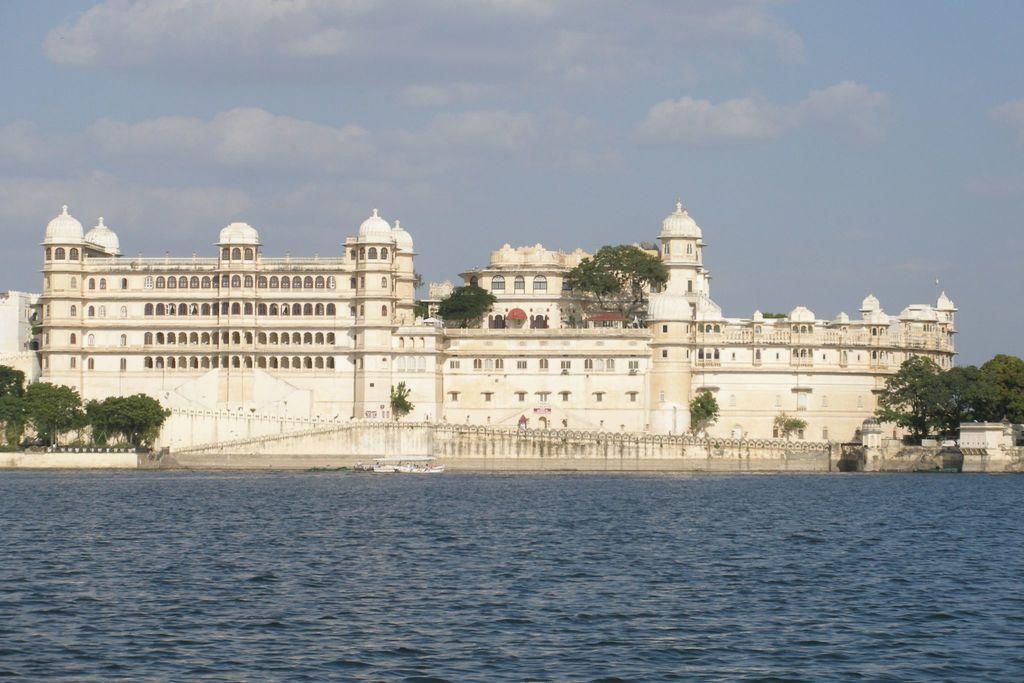How would you summarize this image in a sentence or two? In this image in the foreground there is water body. In the background there is building, trees. The sky is cloudy. 